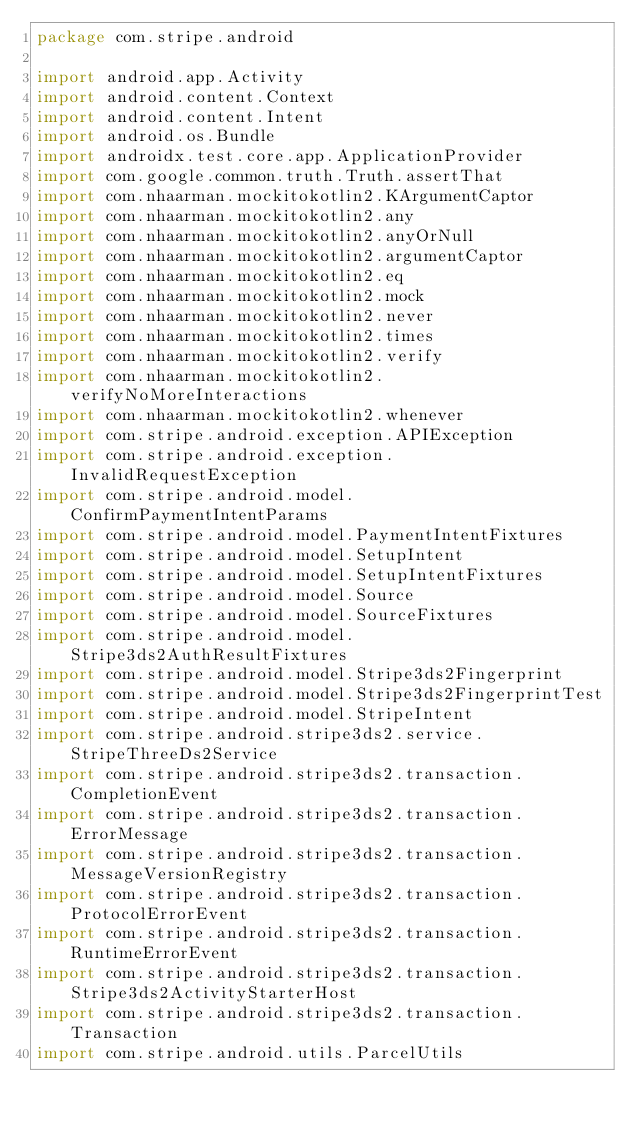<code> <loc_0><loc_0><loc_500><loc_500><_Kotlin_>package com.stripe.android

import android.app.Activity
import android.content.Context
import android.content.Intent
import android.os.Bundle
import androidx.test.core.app.ApplicationProvider
import com.google.common.truth.Truth.assertThat
import com.nhaarman.mockitokotlin2.KArgumentCaptor
import com.nhaarman.mockitokotlin2.any
import com.nhaarman.mockitokotlin2.anyOrNull
import com.nhaarman.mockitokotlin2.argumentCaptor
import com.nhaarman.mockitokotlin2.eq
import com.nhaarman.mockitokotlin2.mock
import com.nhaarman.mockitokotlin2.never
import com.nhaarman.mockitokotlin2.times
import com.nhaarman.mockitokotlin2.verify
import com.nhaarman.mockitokotlin2.verifyNoMoreInteractions
import com.nhaarman.mockitokotlin2.whenever
import com.stripe.android.exception.APIException
import com.stripe.android.exception.InvalidRequestException
import com.stripe.android.model.ConfirmPaymentIntentParams
import com.stripe.android.model.PaymentIntentFixtures
import com.stripe.android.model.SetupIntent
import com.stripe.android.model.SetupIntentFixtures
import com.stripe.android.model.Source
import com.stripe.android.model.SourceFixtures
import com.stripe.android.model.Stripe3ds2AuthResultFixtures
import com.stripe.android.model.Stripe3ds2Fingerprint
import com.stripe.android.model.Stripe3ds2FingerprintTest
import com.stripe.android.model.StripeIntent
import com.stripe.android.stripe3ds2.service.StripeThreeDs2Service
import com.stripe.android.stripe3ds2.transaction.CompletionEvent
import com.stripe.android.stripe3ds2.transaction.ErrorMessage
import com.stripe.android.stripe3ds2.transaction.MessageVersionRegistry
import com.stripe.android.stripe3ds2.transaction.ProtocolErrorEvent
import com.stripe.android.stripe3ds2.transaction.RuntimeErrorEvent
import com.stripe.android.stripe3ds2.transaction.Stripe3ds2ActivityStarterHost
import com.stripe.android.stripe3ds2.transaction.Transaction
import com.stripe.android.utils.ParcelUtils</code> 